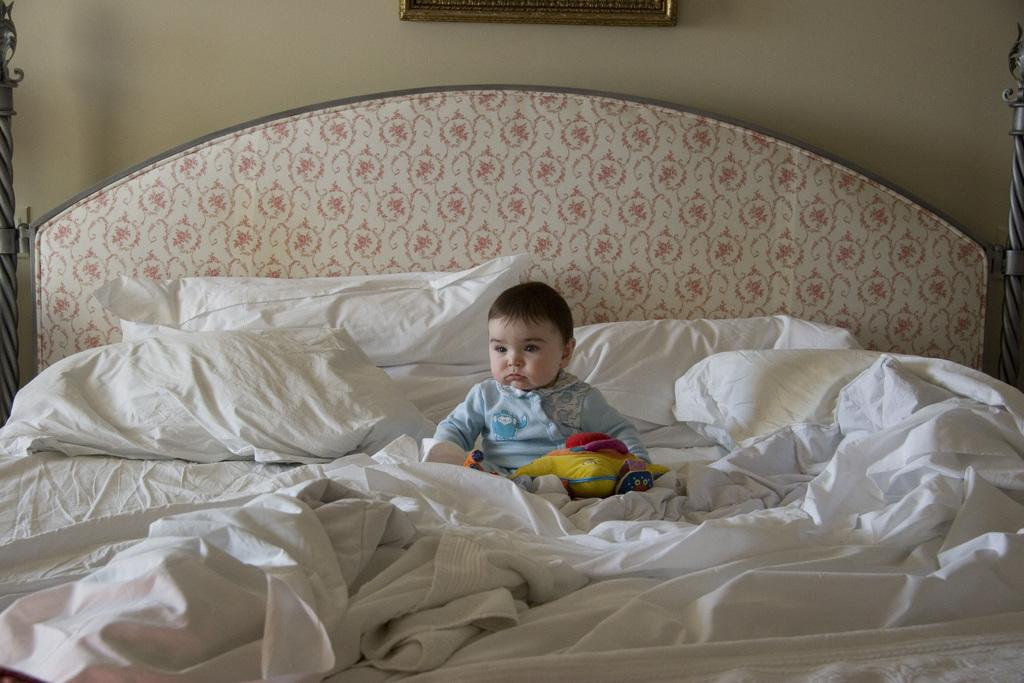What is the main subject of the image? There is a baby in the image. Where is the baby located? The baby is sitting on a bed. What else can be seen in the image besides the baby? There are pillows in the image. What is visible in the background of the image? There is a wall visible in the image. How many wounds can be seen on the baby in the image? There are no visible wounds on the baby in the image. What type of twist is the baby performing in the image? The baby is not performing any twist in the image; they are simply sitting on the bed. 